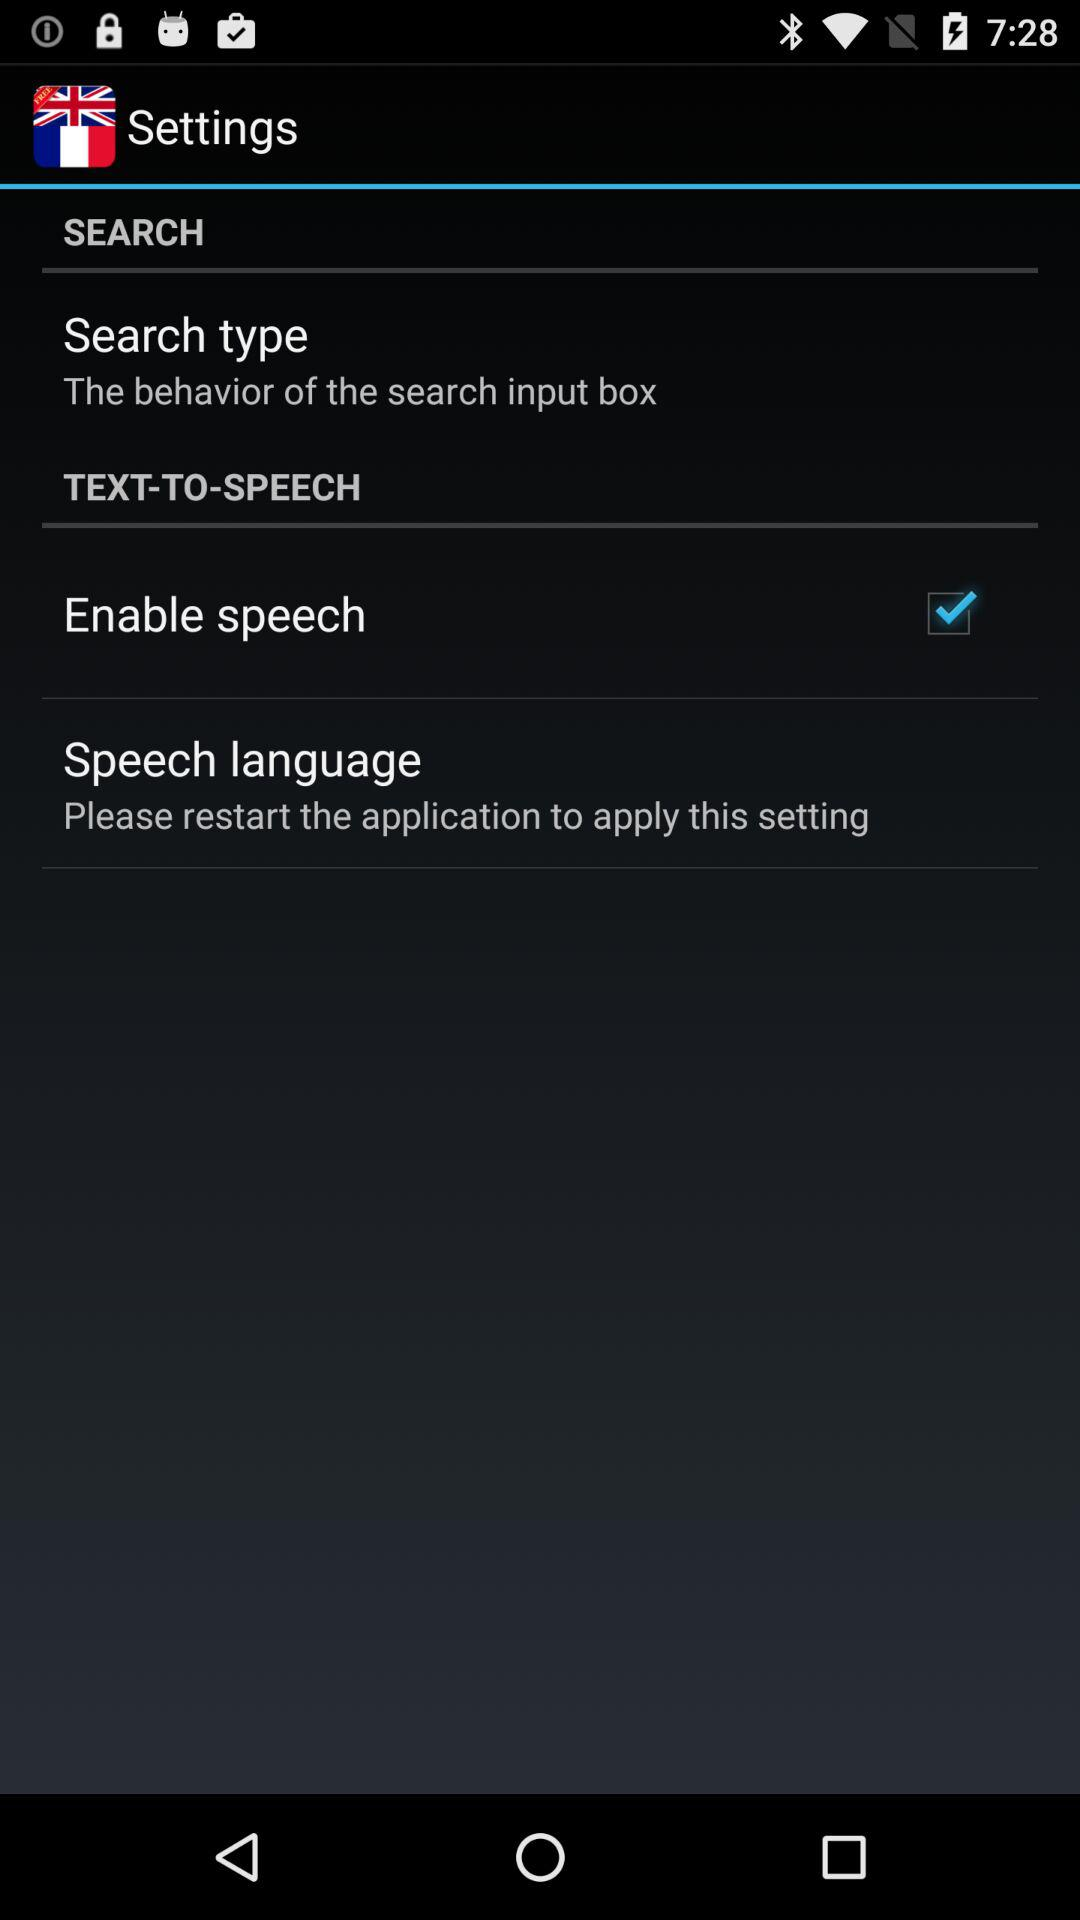What is the status of the "Enable speech" setting? The status is "on". 